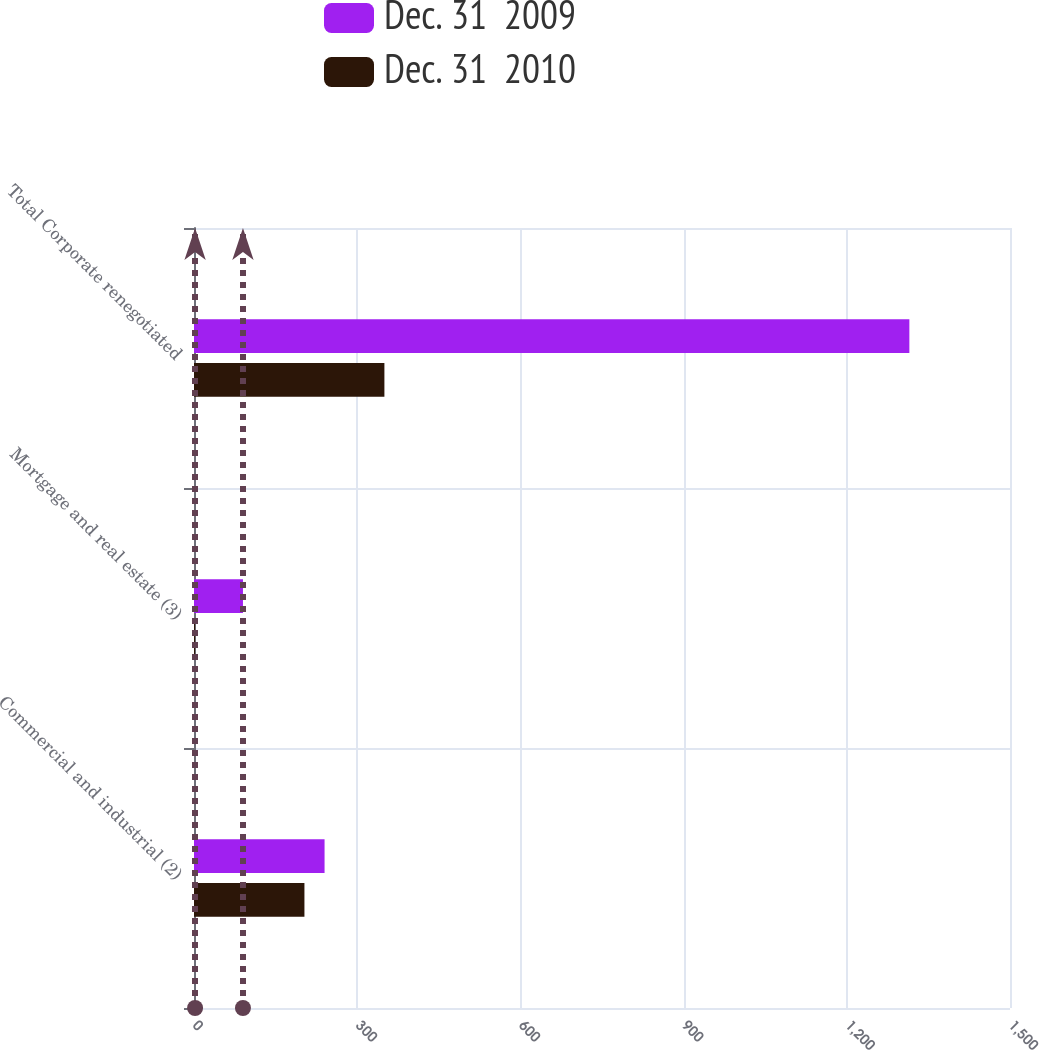<chart> <loc_0><loc_0><loc_500><loc_500><stacked_bar_chart><ecel><fcel>Commercial and industrial (2)<fcel>Mortgage and real estate (3)<fcel>Total Corporate renegotiated<nl><fcel>Dec. 31  2009<fcel>240<fcel>90<fcel>1315<nl><fcel>Dec. 31  2010<fcel>203<fcel>2<fcel>350<nl></chart> 